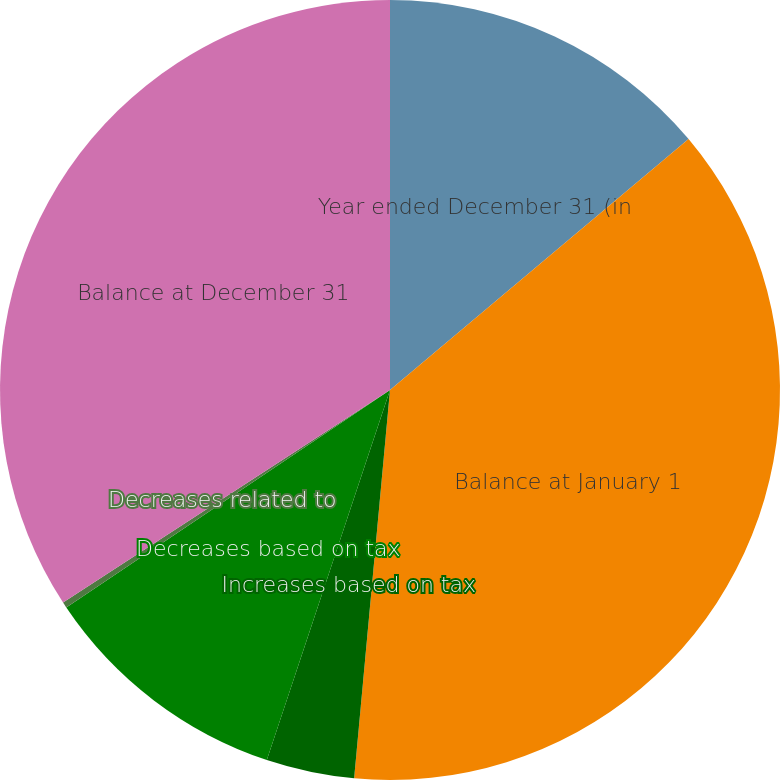<chart> <loc_0><loc_0><loc_500><loc_500><pie_chart><fcel>Year ended December 31 (in<fcel>Balance at January 1<fcel>Increases based on tax<fcel>Decreases based on tax<fcel>Decreases related to<fcel>Balance at December 31<nl><fcel>13.88%<fcel>37.59%<fcel>3.65%<fcel>10.47%<fcel>0.24%<fcel>34.18%<nl></chart> 